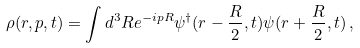Convert formula to latex. <formula><loc_0><loc_0><loc_500><loc_500>\rho ( r , p , t ) = \int d ^ { 3 } R e ^ { - i p R } \psi ^ { \dagger } ( r - \frac { R } { 2 } , t ) \psi ( r + \frac { R } { 2 } , t ) \, ,</formula> 